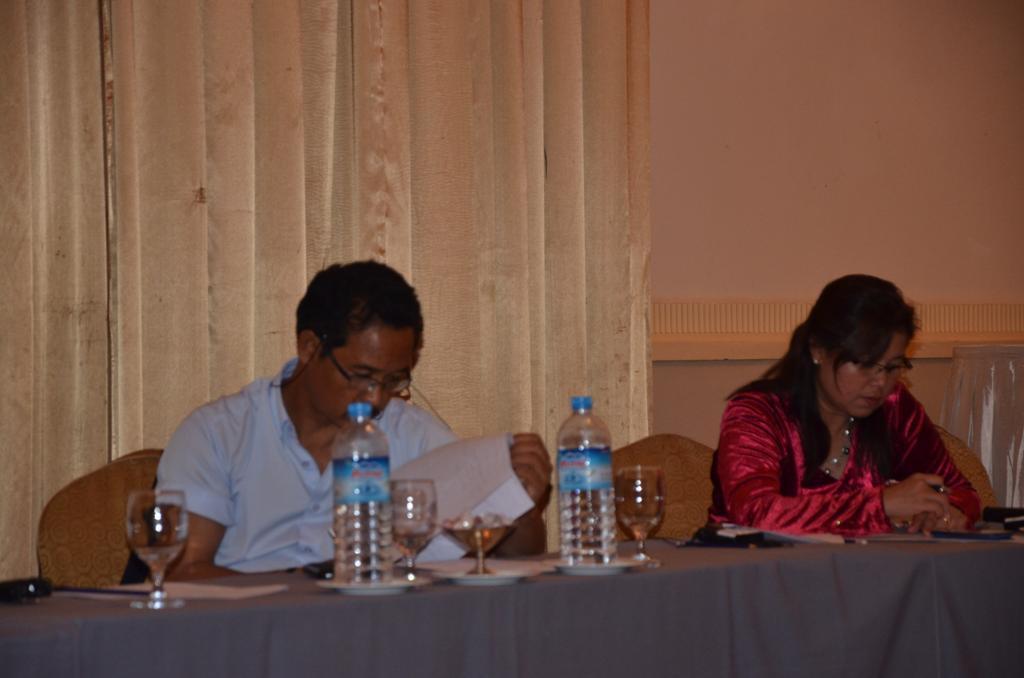Describe this image in one or two sentences. In this picture we can see a man sitting on the chair and his looking into the paper decide there is a woman sitting on the chair and she is looking into the phone there is a table in front of them which is covered with grey color cloth on that table we can see 2 Bottles And 3 glasses which is filled with a liquid back side we can see a cloth. 